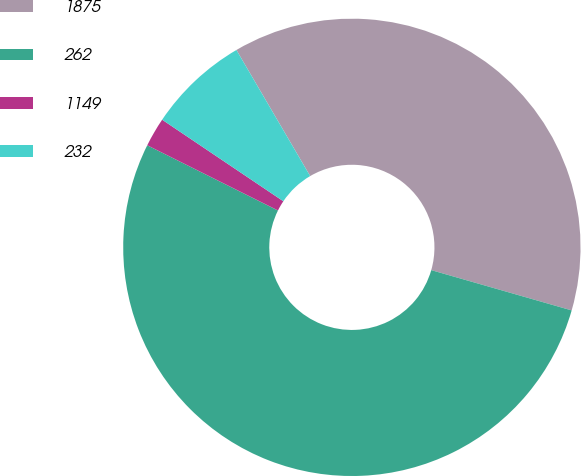<chart> <loc_0><loc_0><loc_500><loc_500><pie_chart><fcel>1875<fcel>262<fcel>1149<fcel>232<nl><fcel>37.87%<fcel>52.92%<fcel>2.06%<fcel>7.15%<nl></chart> 